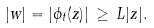Convert formula to latex. <formula><loc_0><loc_0><loc_500><loc_500>| w | = \left | \phi _ { t } ( z ) \right | \, \geq \, L | z | .</formula> 